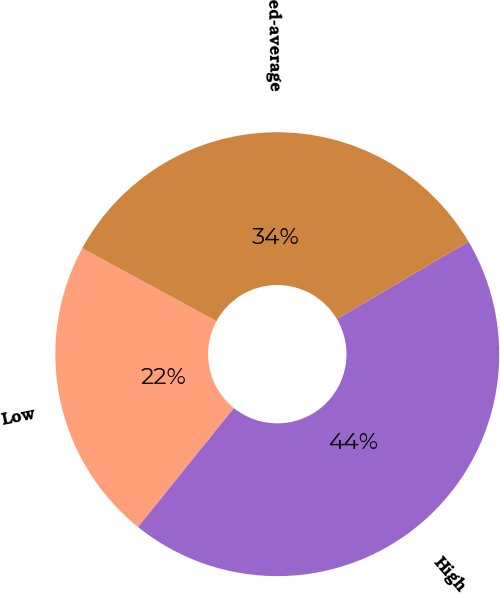Convert chart to OTSL. <chart><loc_0><loc_0><loc_500><loc_500><pie_chart><fcel>Low<fcel>High<fcel>Weighted-average<nl><fcel>22.13%<fcel>44.26%<fcel>33.61%<nl></chart> 